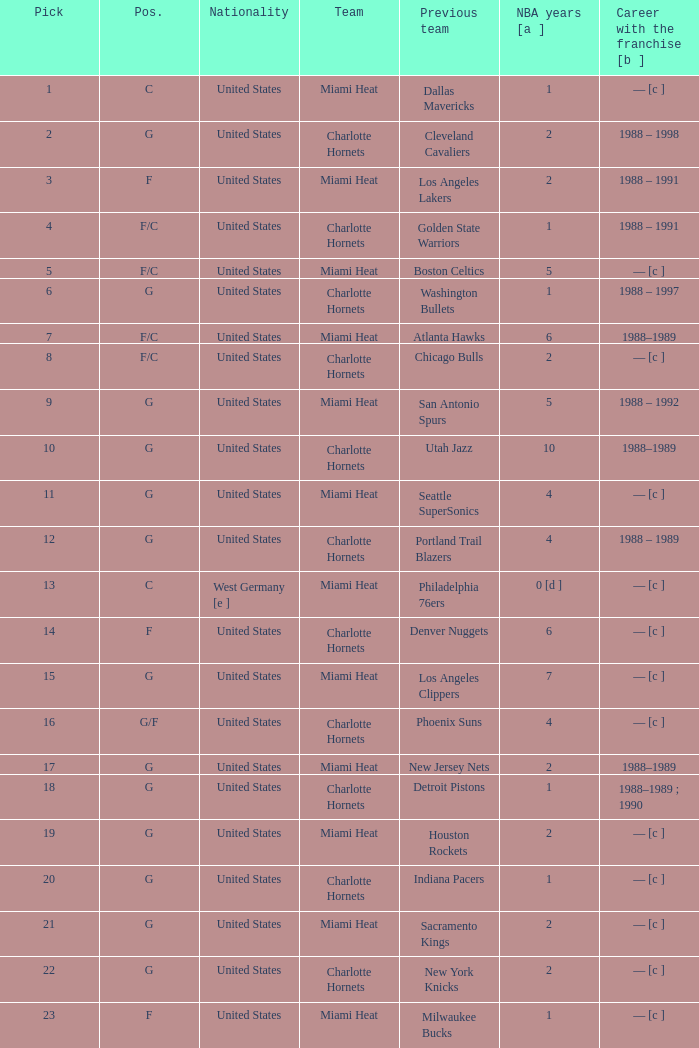What is the team of the player who was previously on the indiana pacers? Charlotte Hornets. 